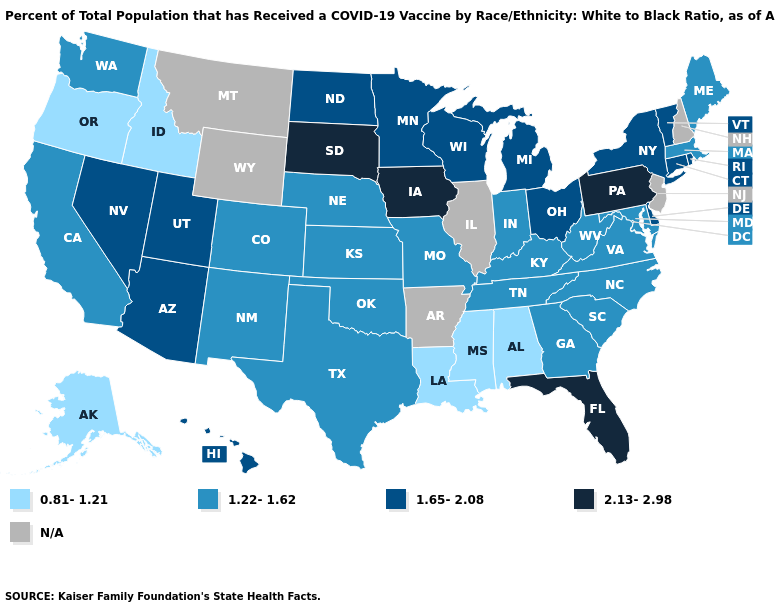What is the highest value in the Northeast ?
Quick response, please. 2.13-2.98. Is the legend a continuous bar?
Quick response, please. No. What is the value of Delaware?
Short answer required. 1.65-2.08. Name the states that have a value in the range 1.65-2.08?
Answer briefly. Arizona, Connecticut, Delaware, Hawaii, Michigan, Minnesota, Nevada, New York, North Dakota, Ohio, Rhode Island, Utah, Vermont, Wisconsin. Does the map have missing data?
Give a very brief answer. Yes. What is the value of Louisiana?
Be succinct. 0.81-1.21. What is the value of Utah?
Short answer required. 1.65-2.08. What is the value of Montana?
Keep it brief. N/A. What is the value of Louisiana?
Answer briefly. 0.81-1.21. Which states have the lowest value in the USA?
Write a very short answer. Alabama, Alaska, Idaho, Louisiana, Mississippi, Oregon. What is the value of Kansas?
Quick response, please. 1.22-1.62. What is the value of Oregon?
Write a very short answer. 0.81-1.21. What is the value of Michigan?
Be succinct. 1.65-2.08. Among the states that border Rhode Island , which have the highest value?
Quick response, please. Connecticut. 